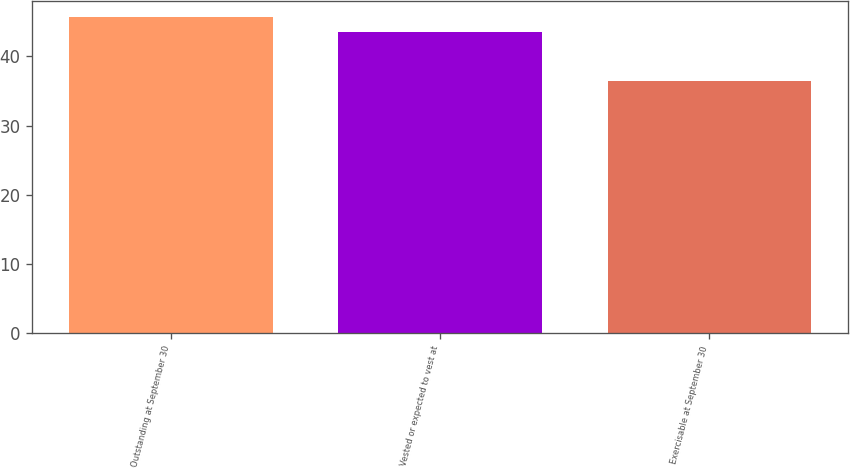Convert chart to OTSL. <chart><loc_0><loc_0><loc_500><loc_500><bar_chart><fcel>Outstanding at September 30<fcel>Vested or expected to vest at<fcel>Exercisable at September 30<nl><fcel>45.69<fcel>43.49<fcel>36.37<nl></chart> 